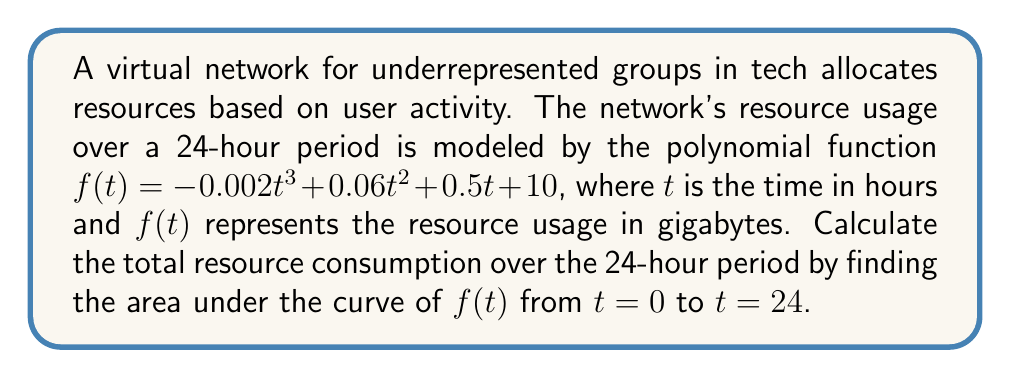Teach me how to tackle this problem. To find the area under the curve, we need to integrate the function $f(t)$ from $t=0$ to $t=24$:

1) First, let's set up the definite integral:
   $$\int_0^{24} (-0.002t^3 + 0.06t^2 + 0.5t + 10) dt$$

2) Now, we integrate each term:
   $$\left[-0.002\frac{t^4}{4} + 0.06\frac{t^3}{3} + 0.5\frac{t^2}{2} + 10t\right]_0^{24}$$

3) Evaluate the integral at the upper and lower bounds:
   At $t=24$:
   $$-0.002\frac{24^4}{4} + 0.06\frac{24^3}{3} + 0.5\frac{24^2}{2} + 10(24)$$
   $$= -69.12 + 276.48 + 144 + 240 = 591.36$$

   At $t=0$:
   $$-0.002\frac{0^4}{4} + 0.06\frac{0^3}{3} + 0.5\frac{0^2}{2} + 10(0) = 0$$

4) Subtract the lower bound from the upper bound:
   $$591.36 - 0 = 591.36$$

Therefore, the total resource consumption over the 24-hour period is 591.36 gigabytes.
Answer: 591.36 GB 